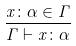Convert formula to latex. <formula><loc_0><loc_0><loc_500><loc_500>\frac { x \colon \alpha \in \Gamma } { \Gamma \vdash x \colon \alpha }</formula> 